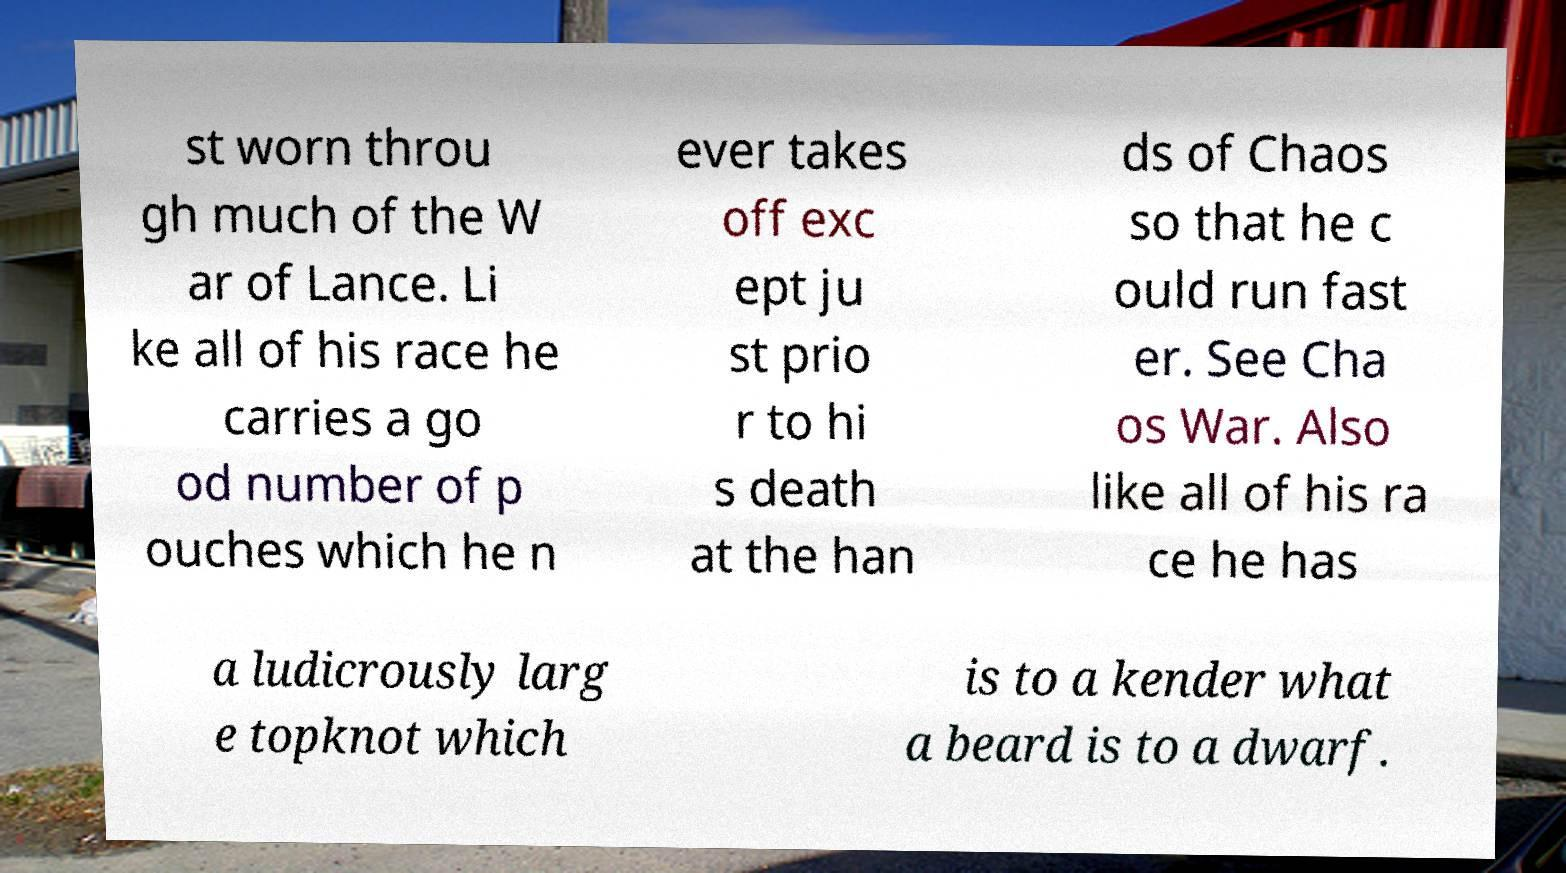For documentation purposes, I need the text within this image transcribed. Could you provide that? st worn throu gh much of the W ar of Lance. Li ke all of his race he carries a go od number of p ouches which he n ever takes off exc ept ju st prio r to hi s death at the han ds of Chaos so that he c ould run fast er. See Cha os War. Also like all of his ra ce he has a ludicrously larg e topknot which is to a kender what a beard is to a dwarf. 